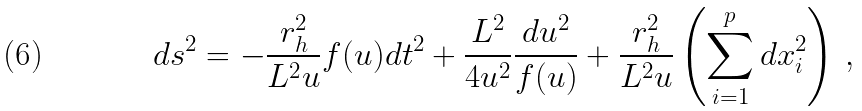Convert formula to latex. <formula><loc_0><loc_0><loc_500><loc_500>d s ^ { 2 } = - \frac { r _ { h } ^ { 2 } } { L ^ { 2 } u } f ( u ) d t ^ { 2 } + \frac { L ^ { 2 } } { 4 u ^ { 2 } } \frac { d u ^ { 2 } } { f ( u ) } + \frac { r _ { h } ^ { 2 } } { L ^ { 2 } u } \left ( \sum _ { i = 1 } ^ { p } d x _ { i } ^ { 2 } \right ) \, ,</formula> 